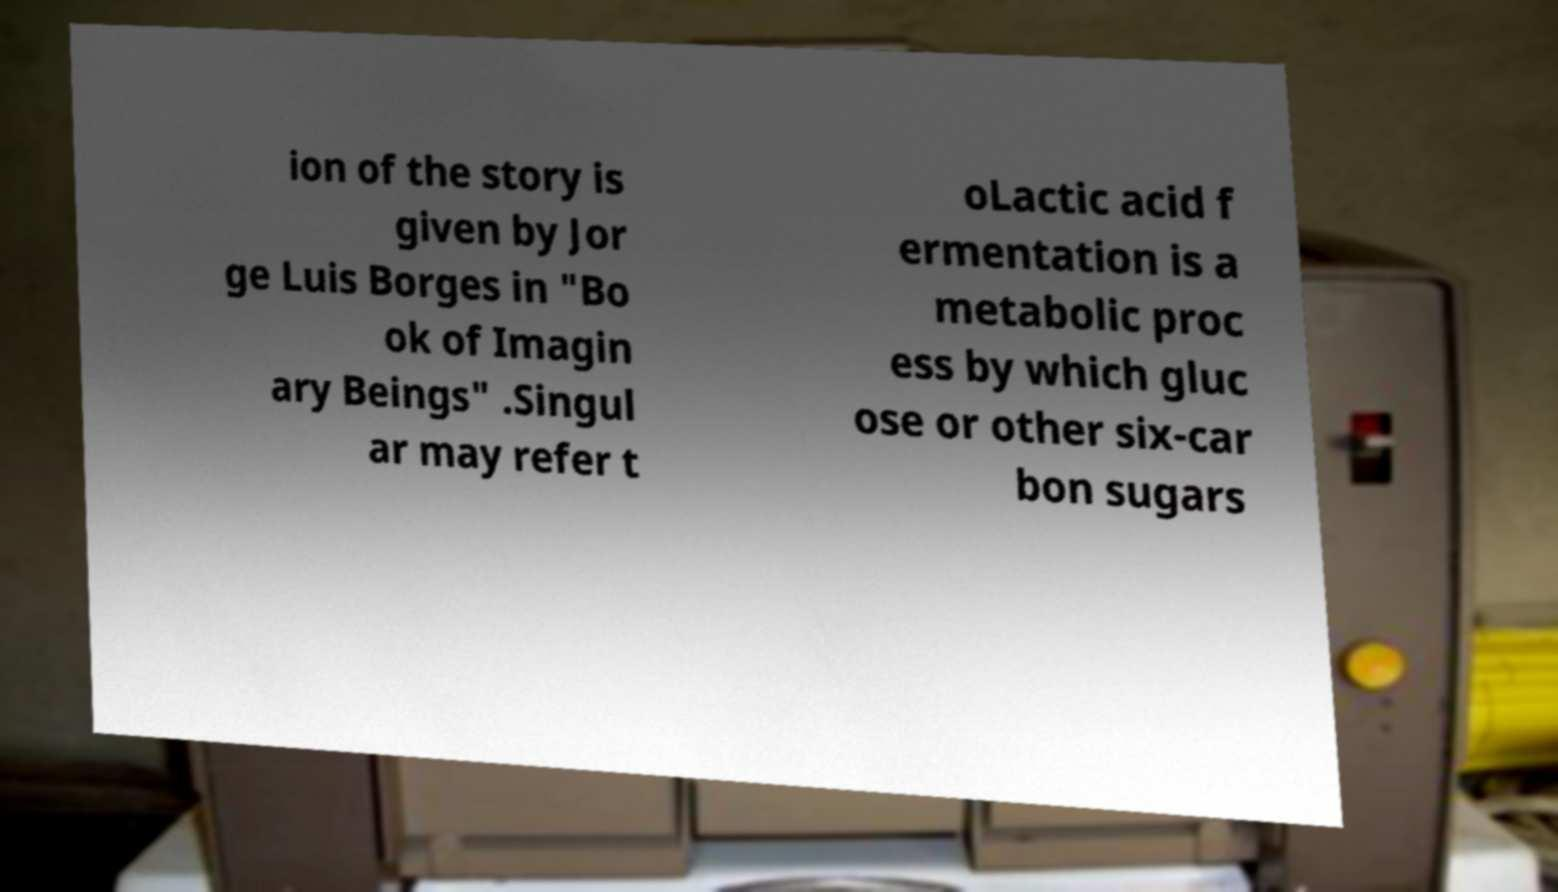Can you accurately transcribe the text from the provided image for me? ion of the story is given by Jor ge Luis Borges in "Bo ok of Imagin ary Beings" .Singul ar may refer t oLactic acid f ermentation is a metabolic proc ess by which gluc ose or other six-car bon sugars 